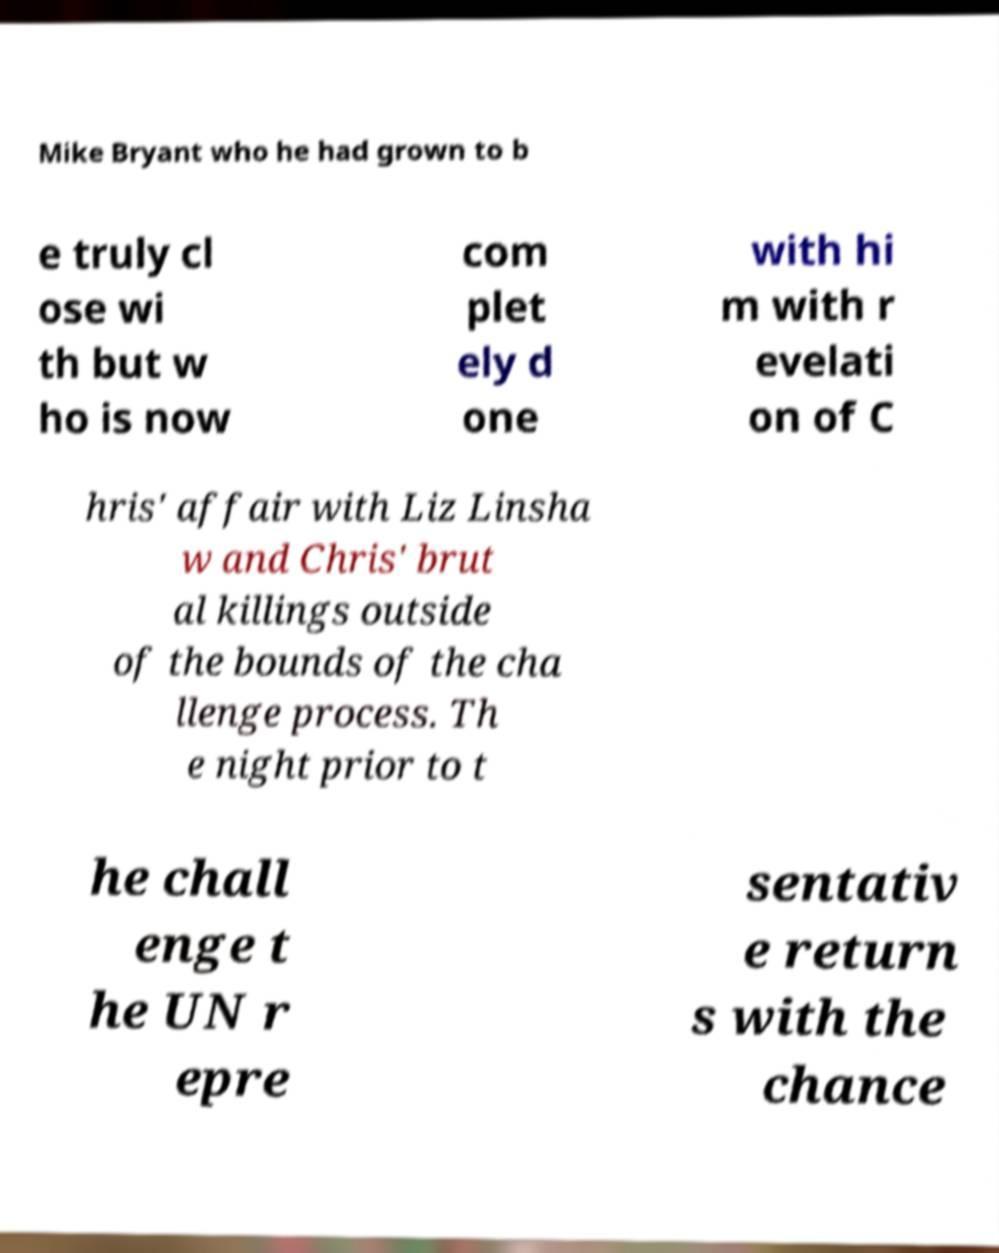There's text embedded in this image that I need extracted. Can you transcribe it verbatim? Mike Bryant who he had grown to b e truly cl ose wi th but w ho is now com plet ely d one with hi m with r evelati on of C hris' affair with Liz Linsha w and Chris' brut al killings outside of the bounds of the cha llenge process. Th e night prior to t he chall enge t he UN r epre sentativ e return s with the chance 